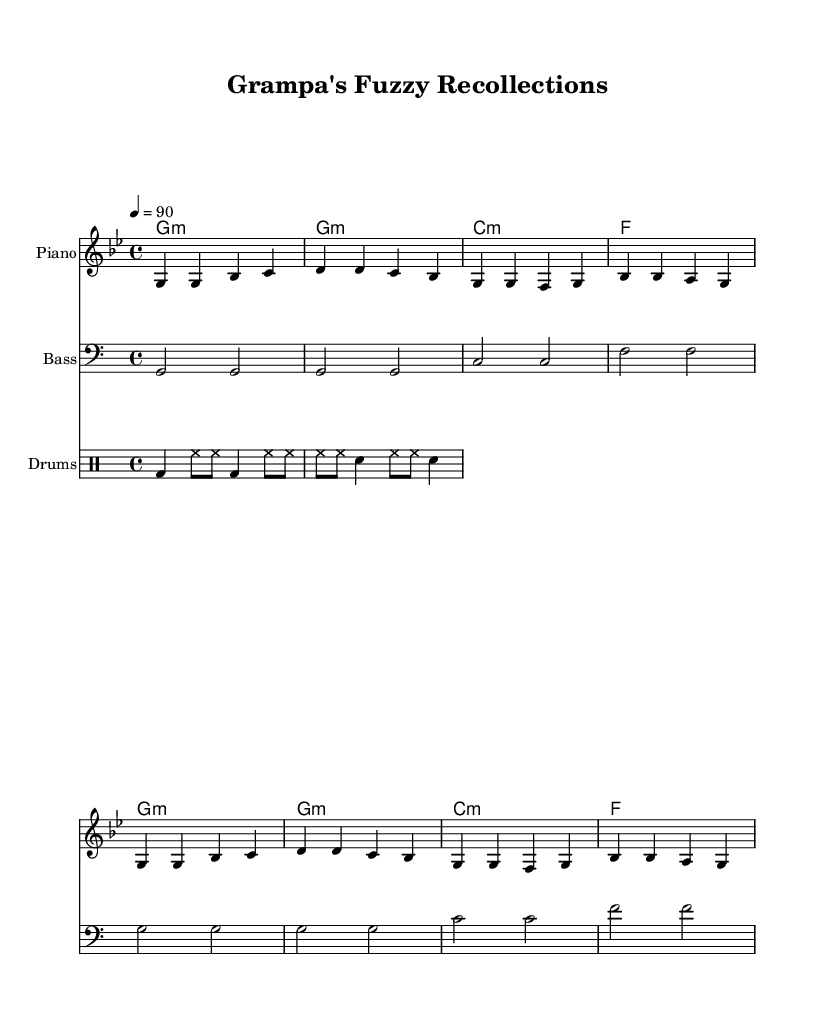What is the title of this piece? The title of the piece is located in the header section of the sheet music, clearly stating "Grampa's Fuzzy Recollections."
Answer: Grampa's Fuzzy Recollections What is the time signature of this music? The time signature is indicated by the fractions displayed in the music sheet. In this case, it is 4/4, which means there are four beats in each measure.
Answer: 4/4 What is the key signature of this piece? The key signature is indicated at the beginning of the music, and here it shows that it is in G minor, which typically has two flats.
Answer: G minor What is the tempo marking? The tempo marking is shown as "4 = 90," indicating the beats per minute for how fast the piece should be played.
Answer: 90 How many measures are in the melody? To find the number of measures, we can count the distinct sets of notes between the vertical lines in the melody part, which results in a total of 8 measures.
Answer: 8 What instrument is playing the melody? The instrument for the melody is specified in the score section, listed as "Piano."
Answer: Piano What is the theme of the lyrics? The lyrics reflect a nostalgic theme about childhood memories, specifically mentioning riding a unicorn or a bike, which captures the essence of looking back fondly on simpler times.
Answer: Nostalgia 